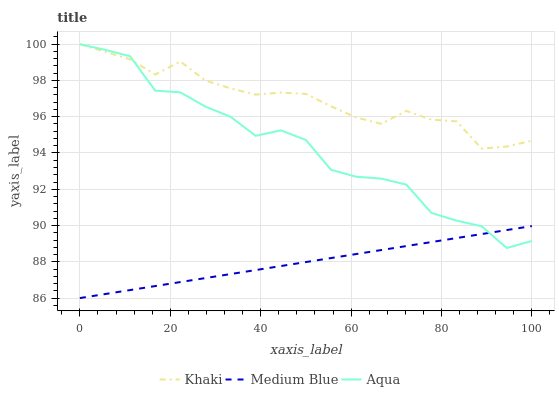Does Medium Blue have the minimum area under the curve?
Answer yes or no. Yes. Does Khaki have the maximum area under the curve?
Answer yes or no. Yes. Does Khaki have the minimum area under the curve?
Answer yes or no. No. Does Medium Blue have the maximum area under the curve?
Answer yes or no. No. Is Medium Blue the smoothest?
Answer yes or no. Yes. Is Aqua the roughest?
Answer yes or no. Yes. Is Khaki the smoothest?
Answer yes or no. No. Is Khaki the roughest?
Answer yes or no. No. Does Khaki have the lowest value?
Answer yes or no. No. Does Khaki have the highest value?
Answer yes or no. Yes. Does Medium Blue have the highest value?
Answer yes or no. No. Is Medium Blue less than Khaki?
Answer yes or no. Yes. Is Khaki greater than Medium Blue?
Answer yes or no. Yes. Does Aqua intersect Medium Blue?
Answer yes or no. Yes. Is Aqua less than Medium Blue?
Answer yes or no. No. Is Aqua greater than Medium Blue?
Answer yes or no. No. Does Medium Blue intersect Khaki?
Answer yes or no. No. 